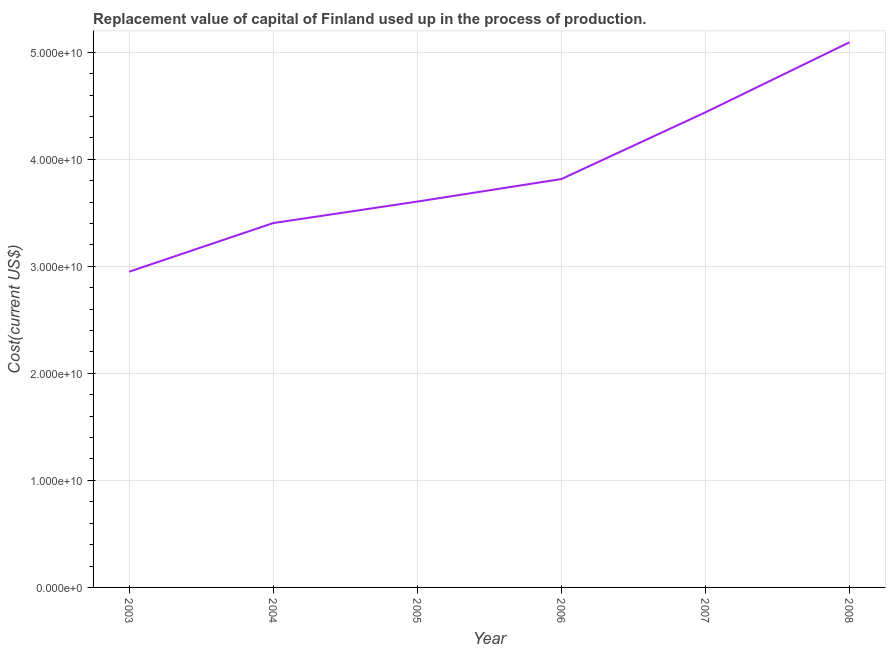What is the consumption of fixed capital in 2004?
Make the answer very short. 3.40e+1. Across all years, what is the maximum consumption of fixed capital?
Your response must be concise. 5.09e+1. Across all years, what is the minimum consumption of fixed capital?
Your answer should be very brief. 2.95e+1. In which year was the consumption of fixed capital maximum?
Offer a very short reply. 2008. What is the sum of the consumption of fixed capital?
Ensure brevity in your answer.  2.33e+11. What is the difference between the consumption of fixed capital in 2003 and 2004?
Ensure brevity in your answer.  -4.54e+09. What is the average consumption of fixed capital per year?
Provide a short and direct response. 3.88e+1. What is the median consumption of fixed capital?
Provide a succinct answer. 3.71e+1. In how many years, is the consumption of fixed capital greater than 2000000000 US$?
Your answer should be compact. 6. Do a majority of the years between 2006 and 2003 (inclusive) have consumption of fixed capital greater than 16000000000 US$?
Give a very brief answer. Yes. What is the ratio of the consumption of fixed capital in 2004 to that in 2008?
Your answer should be compact. 0.67. Is the consumption of fixed capital in 2003 less than that in 2008?
Your response must be concise. Yes. What is the difference between the highest and the second highest consumption of fixed capital?
Keep it short and to the point. 6.54e+09. Is the sum of the consumption of fixed capital in 2003 and 2004 greater than the maximum consumption of fixed capital across all years?
Provide a short and direct response. Yes. What is the difference between the highest and the lowest consumption of fixed capital?
Your answer should be very brief. 2.14e+1. Does the consumption of fixed capital monotonically increase over the years?
Ensure brevity in your answer.  Yes. How many years are there in the graph?
Your answer should be very brief. 6. What is the title of the graph?
Your answer should be compact. Replacement value of capital of Finland used up in the process of production. What is the label or title of the Y-axis?
Make the answer very short. Cost(current US$). What is the Cost(current US$) of 2003?
Your answer should be compact. 2.95e+1. What is the Cost(current US$) of 2004?
Offer a terse response. 3.40e+1. What is the Cost(current US$) in 2005?
Provide a short and direct response. 3.60e+1. What is the Cost(current US$) in 2006?
Ensure brevity in your answer.  3.81e+1. What is the Cost(current US$) of 2007?
Your response must be concise. 4.44e+1. What is the Cost(current US$) of 2008?
Ensure brevity in your answer.  5.09e+1. What is the difference between the Cost(current US$) in 2003 and 2004?
Offer a terse response. -4.54e+09. What is the difference between the Cost(current US$) in 2003 and 2005?
Your answer should be very brief. -6.55e+09. What is the difference between the Cost(current US$) in 2003 and 2006?
Your response must be concise. -8.66e+09. What is the difference between the Cost(current US$) in 2003 and 2007?
Make the answer very short. -1.49e+1. What is the difference between the Cost(current US$) in 2003 and 2008?
Your response must be concise. -2.14e+1. What is the difference between the Cost(current US$) in 2004 and 2005?
Make the answer very short. -2.01e+09. What is the difference between the Cost(current US$) in 2004 and 2006?
Provide a succinct answer. -4.11e+09. What is the difference between the Cost(current US$) in 2004 and 2007?
Your answer should be very brief. -1.03e+1. What is the difference between the Cost(current US$) in 2004 and 2008?
Offer a very short reply. -1.69e+1. What is the difference between the Cost(current US$) in 2005 and 2006?
Your answer should be compact. -2.10e+09. What is the difference between the Cost(current US$) in 2005 and 2007?
Your answer should be compact. -8.34e+09. What is the difference between the Cost(current US$) in 2005 and 2008?
Your answer should be very brief. -1.49e+1. What is the difference between the Cost(current US$) in 2006 and 2007?
Provide a succinct answer. -6.23e+09. What is the difference between the Cost(current US$) in 2006 and 2008?
Provide a succinct answer. -1.28e+1. What is the difference between the Cost(current US$) in 2007 and 2008?
Ensure brevity in your answer.  -6.54e+09. What is the ratio of the Cost(current US$) in 2003 to that in 2004?
Make the answer very short. 0.87. What is the ratio of the Cost(current US$) in 2003 to that in 2005?
Make the answer very short. 0.82. What is the ratio of the Cost(current US$) in 2003 to that in 2006?
Ensure brevity in your answer.  0.77. What is the ratio of the Cost(current US$) in 2003 to that in 2007?
Your answer should be compact. 0.67. What is the ratio of the Cost(current US$) in 2003 to that in 2008?
Make the answer very short. 0.58. What is the ratio of the Cost(current US$) in 2004 to that in 2005?
Provide a short and direct response. 0.94. What is the ratio of the Cost(current US$) in 2004 to that in 2006?
Make the answer very short. 0.89. What is the ratio of the Cost(current US$) in 2004 to that in 2007?
Give a very brief answer. 0.77. What is the ratio of the Cost(current US$) in 2004 to that in 2008?
Provide a succinct answer. 0.67. What is the ratio of the Cost(current US$) in 2005 to that in 2006?
Your answer should be compact. 0.94. What is the ratio of the Cost(current US$) in 2005 to that in 2007?
Make the answer very short. 0.81. What is the ratio of the Cost(current US$) in 2005 to that in 2008?
Give a very brief answer. 0.71. What is the ratio of the Cost(current US$) in 2006 to that in 2007?
Provide a short and direct response. 0.86. What is the ratio of the Cost(current US$) in 2006 to that in 2008?
Your answer should be very brief. 0.75. What is the ratio of the Cost(current US$) in 2007 to that in 2008?
Keep it short and to the point. 0.87. 